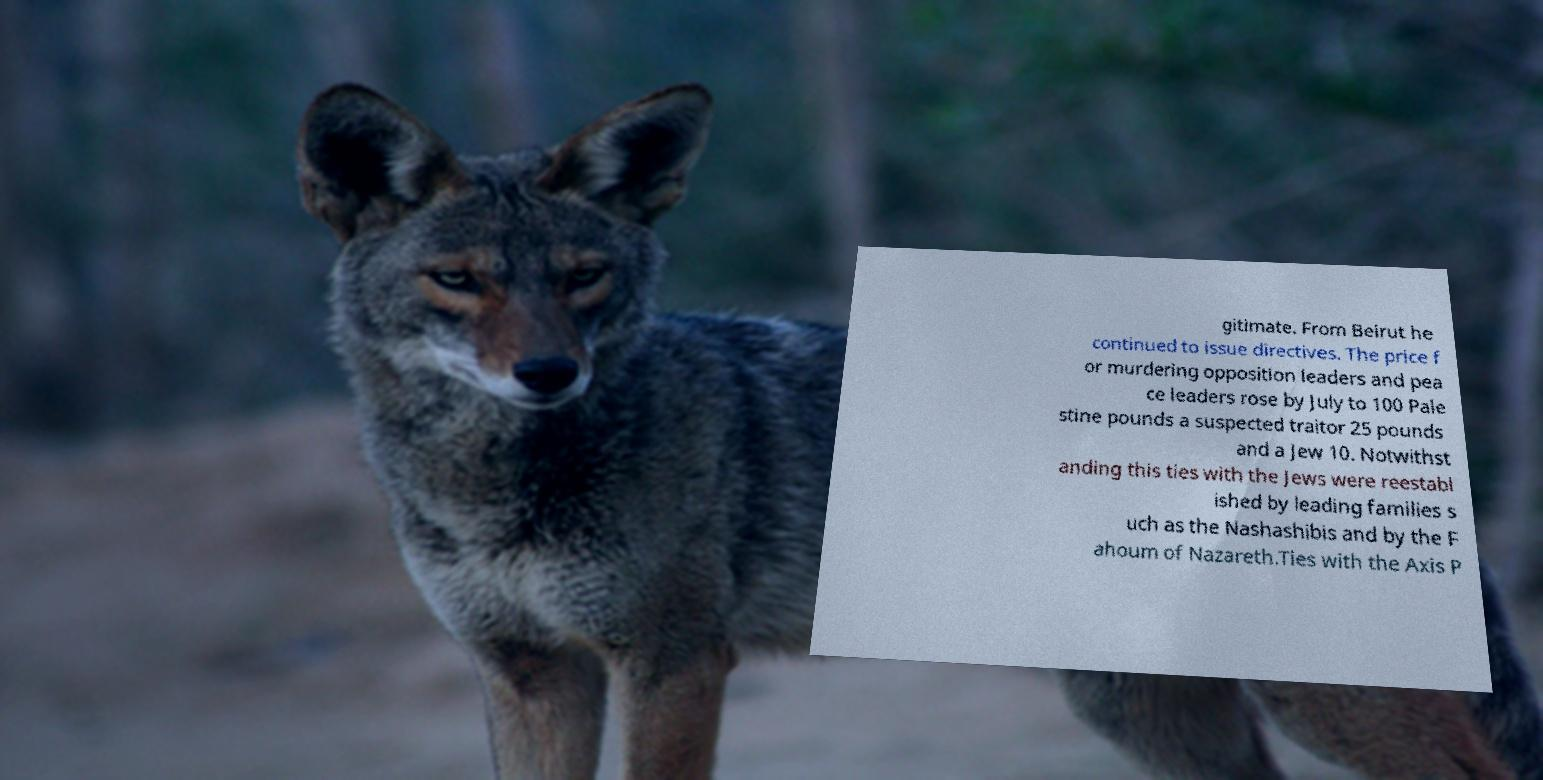There's text embedded in this image that I need extracted. Can you transcribe it verbatim? gitimate. From Beirut he continued to issue directives. The price f or murdering opposition leaders and pea ce leaders rose by July to 100 Pale stine pounds a suspected traitor 25 pounds and a Jew 10. Notwithst anding this ties with the Jews were reestabl ished by leading families s uch as the Nashashibis and by the F ahoum of Nazareth.Ties with the Axis P 